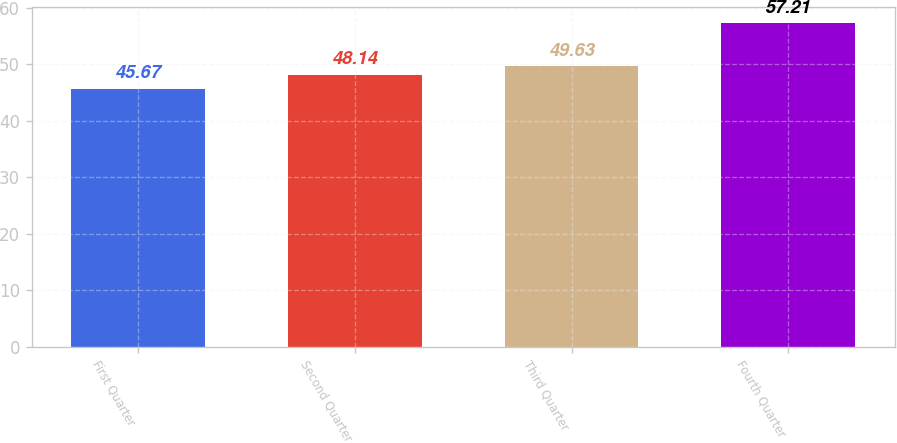Convert chart to OTSL. <chart><loc_0><loc_0><loc_500><loc_500><bar_chart><fcel>First Quarter<fcel>Second Quarter<fcel>Third Quarter<fcel>Fourth Quarter<nl><fcel>45.67<fcel>48.14<fcel>49.63<fcel>57.21<nl></chart> 